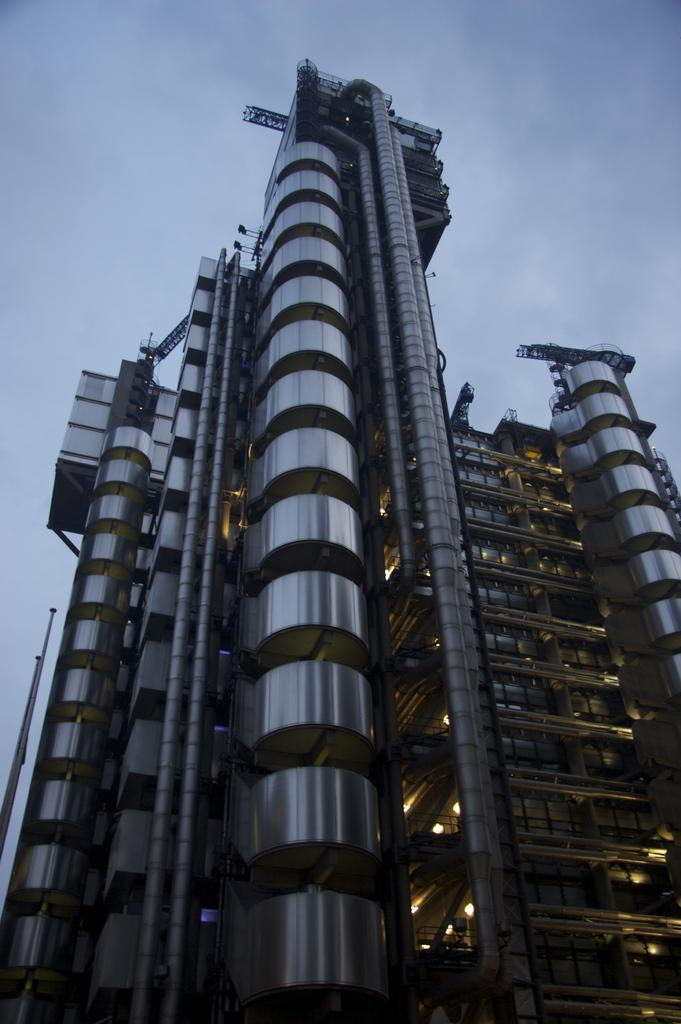What is the main subject in the image? There is a building in the image. What color is the background of the image? The background of the image is blue. Can you see a pickle on the roof of the building in the image? There is no pickle present on the roof of the building in the image. Is there a game of chess being played in the image? There is no game of chess visible in the image. 